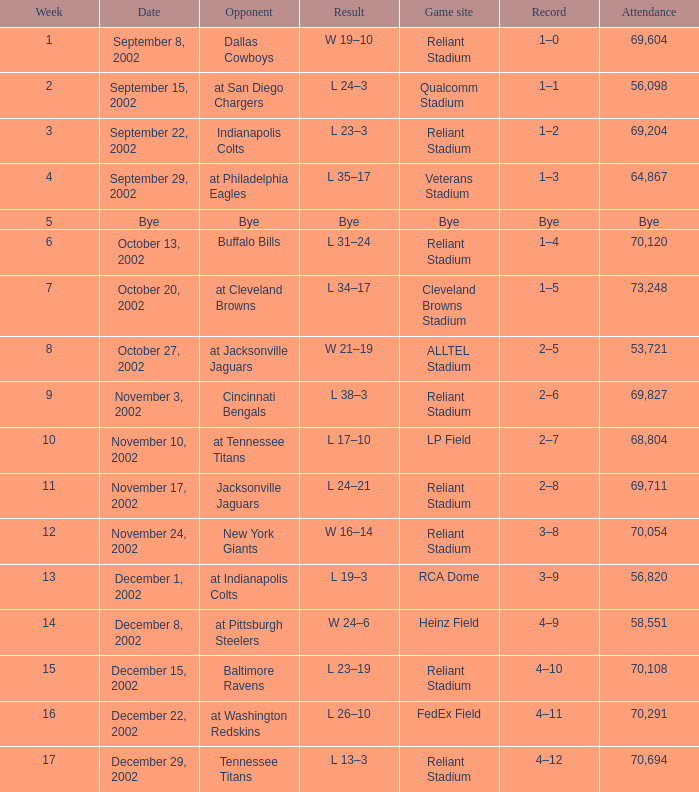Would you mind parsing the complete table? {'header': ['Week', 'Date', 'Opponent', 'Result', 'Game site', 'Record', 'Attendance'], 'rows': [['1', 'September 8, 2002', 'Dallas Cowboys', 'W 19–10', 'Reliant Stadium', '1–0', '69,604'], ['2', 'September 15, 2002', 'at San Diego Chargers', 'L 24–3', 'Qualcomm Stadium', '1–1', '56,098'], ['3', 'September 22, 2002', 'Indianapolis Colts', 'L 23–3', 'Reliant Stadium', '1–2', '69,204'], ['4', 'September 29, 2002', 'at Philadelphia Eagles', 'L 35–17', 'Veterans Stadium', '1–3', '64,867'], ['5', 'Bye', 'Bye', 'Bye', 'Bye', 'Bye', 'Bye'], ['6', 'October 13, 2002', 'Buffalo Bills', 'L 31–24', 'Reliant Stadium', '1–4', '70,120'], ['7', 'October 20, 2002', 'at Cleveland Browns', 'L 34–17', 'Cleveland Browns Stadium', '1–5', '73,248'], ['8', 'October 27, 2002', 'at Jacksonville Jaguars', 'W 21–19', 'ALLTEL Stadium', '2–5', '53,721'], ['9', 'November 3, 2002', 'Cincinnati Bengals', 'L 38–3', 'Reliant Stadium', '2–6', '69,827'], ['10', 'November 10, 2002', 'at Tennessee Titans', 'L 17–10', 'LP Field', '2–7', '68,804'], ['11', 'November 17, 2002', 'Jacksonville Jaguars', 'L 24–21', 'Reliant Stadium', '2–8', '69,711'], ['12', 'November 24, 2002', 'New York Giants', 'W 16–14', 'Reliant Stadium', '3–8', '70,054'], ['13', 'December 1, 2002', 'at Indianapolis Colts', 'L 19–3', 'RCA Dome', '3–9', '56,820'], ['14', 'December 8, 2002', 'at Pittsburgh Steelers', 'W 24–6', 'Heinz Field', '4–9', '58,551'], ['15', 'December 15, 2002', 'Baltimore Ravens', 'L 23–19', 'Reliant Stadium', '4–10', '70,108'], ['16', 'December 22, 2002', 'at Washington Redskins', 'L 26–10', 'FedEx Field', '4–11', '70,291'], ['17', 'December 29, 2002', 'Tennessee Titans', 'L 13–3', 'Reliant Stadium', '4–12', '70,694']]} When did the Texans play at LP Field? November 10, 2002. 